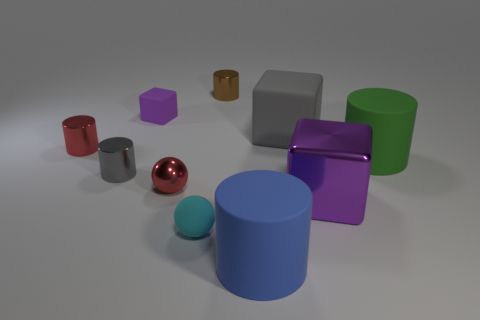Subtract all gray cylinders. How many cylinders are left? 4 Subtract all green cylinders. How many cylinders are left? 4 Subtract all yellow cylinders. Subtract all cyan cubes. How many cylinders are left? 5 Subtract all balls. How many objects are left? 8 Subtract all big brown cubes. Subtract all green rubber objects. How many objects are left? 9 Add 3 tiny cyan matte spheres. How many tiny cyan matte spheres are left? 4 Add 8 matte cylinders. How many matte cylinders exist? 10 Subtract 0 cyan blocks. How many objects are left? 10 